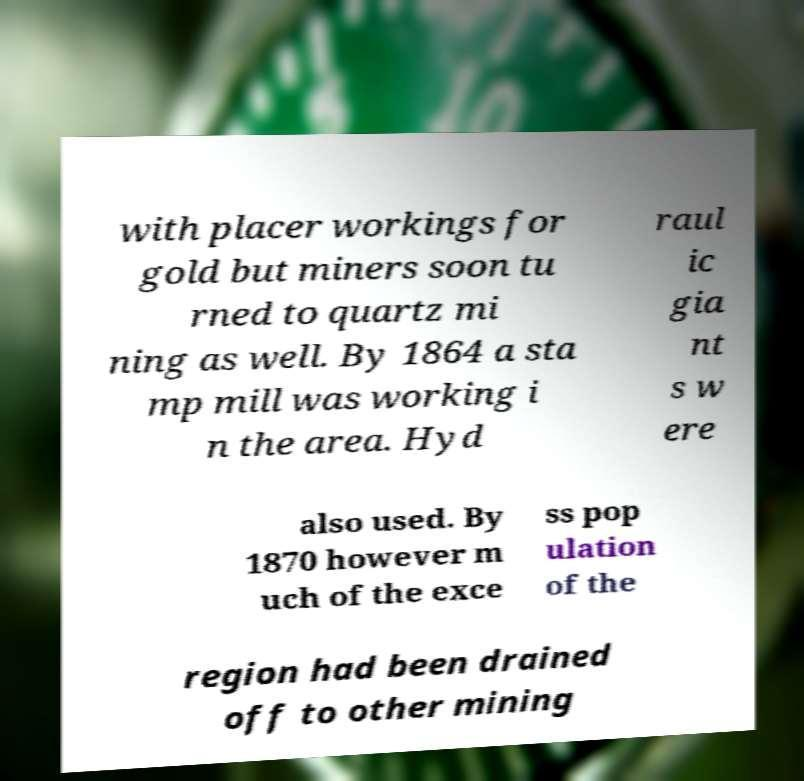For documentation purposes, I need the text within this image transcribed. Could you provide that? with placer workings for gold but miners soon tu rned to quartz mi ning as well. By 1864 a sta mp mill was working i n the area. Hyd raul ic gia nt s w ere also used. By 1870 however m uch of the exce ss pop ulation of the region had been drained off to other mining 